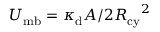<formula> <loc_0><loc_0><loc_500><loc_500>U _ { m b } = \kappa _ { d } A / 2 { R _ { c y } } ^ { 2 }</formula> 